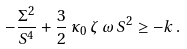<formula> <loc_0><loc_0><loc_500><loc_500>- \frac { \Sigma ^ { 2 } } { S ^ { 4 } } + \frac { 3 } { 2 } \, \kappa _ { 0 } \, \zeta \, \omega \, S ^ { 2 } \geq - k \, .</formula> 